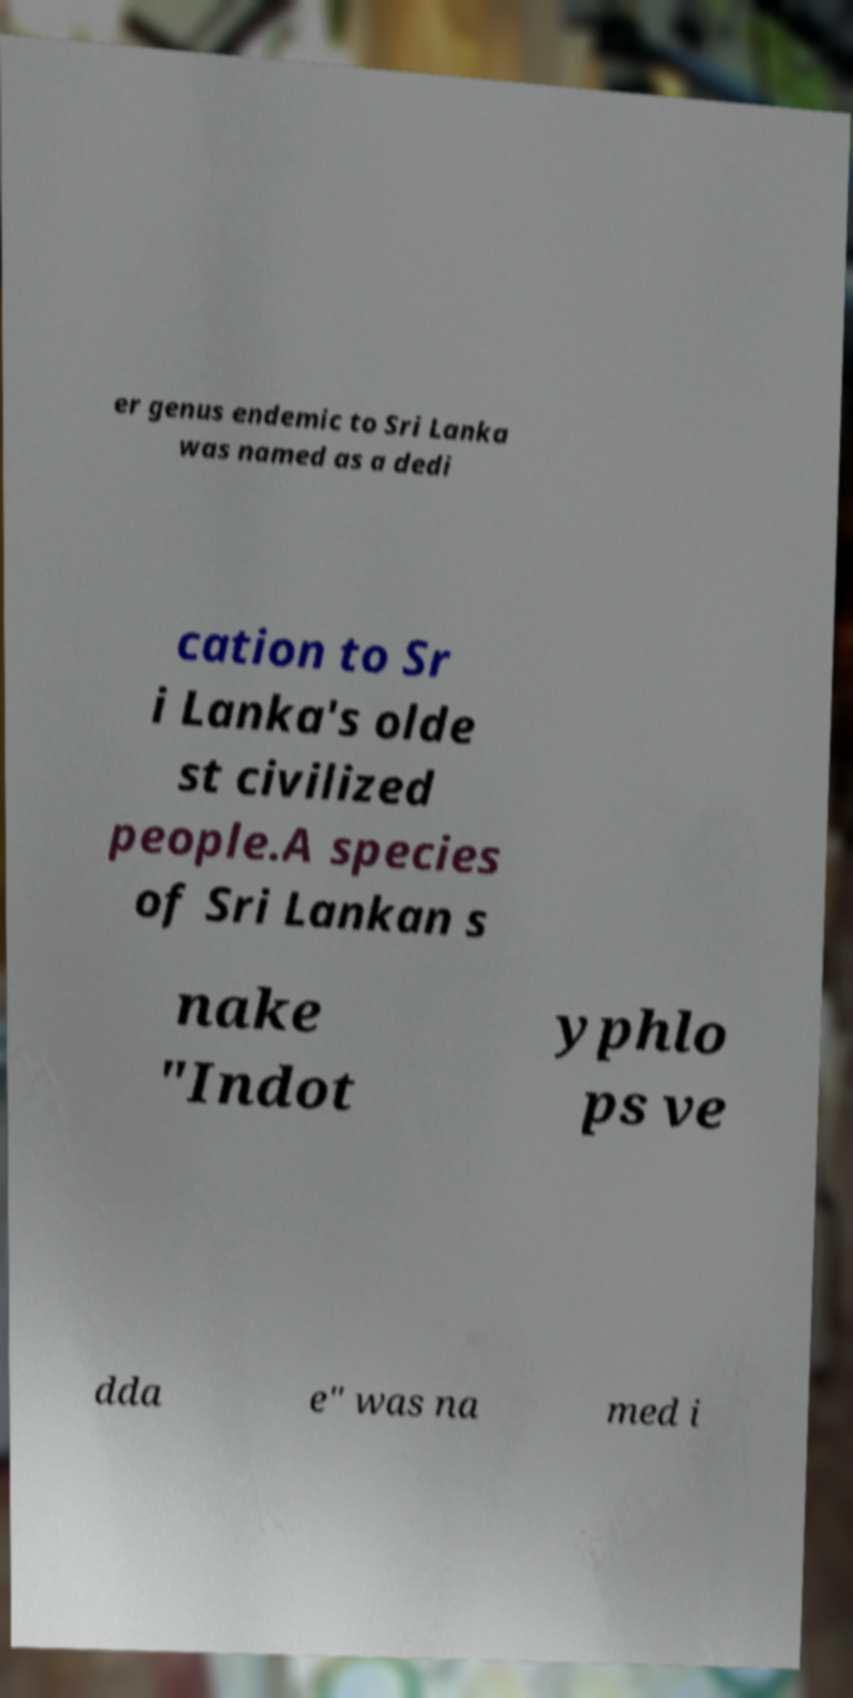Could you extract and type out the text from this image? er genus endemic to Sri Lanka was named as a dedi cation to Sr i Lanka's olde st civilized people.A species of Sri Lankan s nake "Indot yphlo ps ve dda e" was na med i 